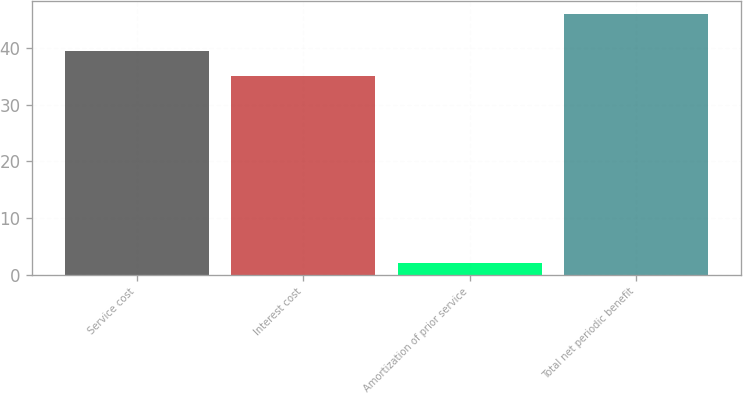Convert chart to OTSL. <chart><loc_0><loc_0><loc_500><loc_500><bar_chart><fcel>Service cost<fcel>Interest cost<fcel>Amortization of prior service<fcel>Total net periodic benefit<nl><fcel>39.4<fcel>35<fcel>2<fcel>46<nl></chart> 